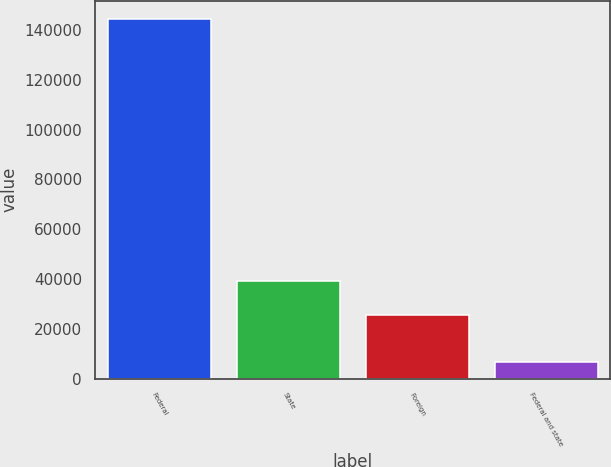Convert chart. <chart><loc_0><loc_0><loc_500><loc_500><bar_chart><fcel>Federal<fcel>State<fcel>Foreign<fcel>Federal and state<nl><fcel>144520<fcel>39258.1<fcel>25466<fcel>6599<nl></chart> 